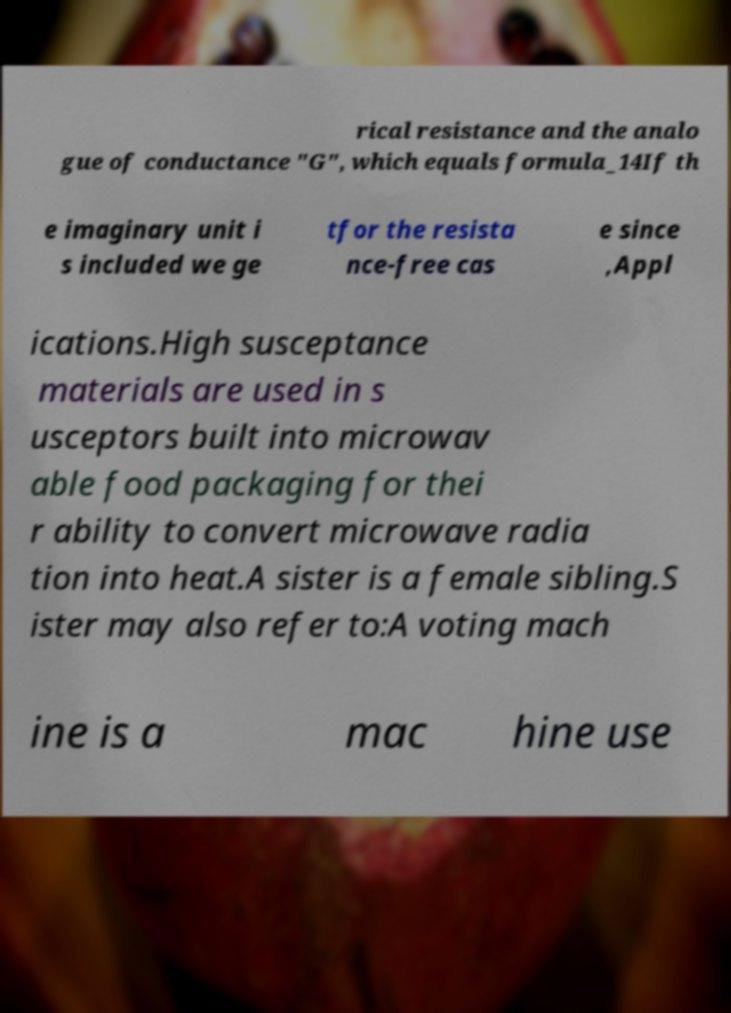Please identify and transcribe the text found in this image. rical resistance and the analo gue of conductance "G", which equals formula_14If th e imaginary unit i s included we ge tfor the resista nce-free cas e since ,Appl ications.High susceptance materials are used in s usceptors built into microwav able food packaging for thei r ability to convert microwave radia tion into heat.A sister is a female sibling.S ister may also refer to:A voting mach ine is a mac hine use 